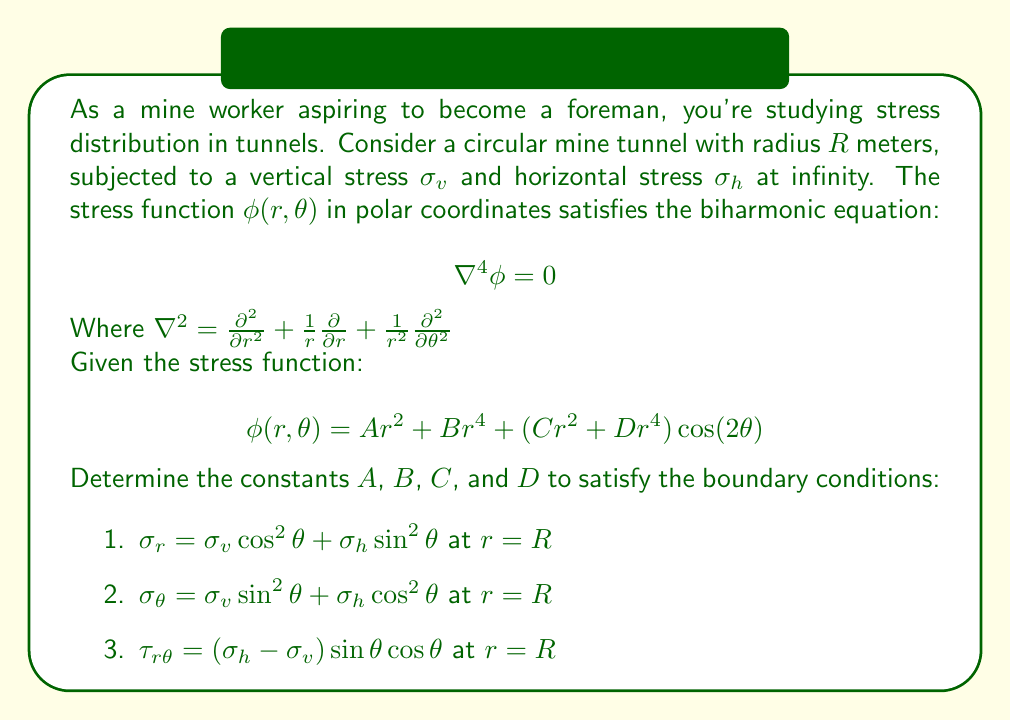Can you answer this question? Let's solve this step-by-step:

1) First, we need to express $\sigma_r$, $\sigma_\theta$, and $\tau_{r\theta}$ in terms of $\phi$:

   $$\sigma_r = \frac{1}{r}\frac{\partial \phi}{\partial r} + \frac{1}{r^2}\frac{\partial^2 \phi}{\partial \theta^2}$$
   $$\sigma_\theta = \frac{\partial^2 \phi}{\partial r^2}$$
   $$\tau_{r\theta} = -\frac{\partial}{\partial r}\left(\frac{1}{r}\frac{\partial \phi}{\partial \theta}\right)$$

2) Substituting the given $\phi(r,\theta)$ into these equations:

   $$\sigma_r = 2A + 4Br^2 + (2C + 4Dr^2)\cos(2\theta)$$
   $$\sigma_\theta = 2A + 12Br^2 + (2C + 12Dr^2)\cos(2\theta)$$
   $$\tau_{r\theta} = (-2C - 4Dr^2)\sin(2\theta)$$

3) Applying the boundary conditions at $r = R$:

   $$2A + 4BR^2 + (2C + 4DR^2)\cos(2\theta) = \sigma_v \cos^2\theta + \sigma_h \sin^2\theta$$
   $$2A + 12BR^2 + (2C + 12DR^2)\cos(2\theta) = \sigma_v \sin^2\theta + \sigma_h \cos^2\theta$$
   $$(-2C - 4DR^2)\sin(2\theta) = (\sigma_h - \sigma_v) \sin\theta \cos\theta$$

4) Using trigonometric identities:

   $$\cos^2\theta = \frac{1 + \cos(2\theta)}{2}, \sin^2\theta = \frac{1 - \cos(2\theta)}{2}$$
   $$\sin\theta \cos\theta = \frac{1}{2}\sin(2\theta)$$

5) Rewriting the boundary conditions:

   $$2A + 4BR^2 + (2C + 4DR^2)\cos(2\theta) = \frac{\sigma_v + \sigma_h}{2} + \frac{\sigma_v - \sigma_h}{2}\cos(2\theta)$$
   $$2A + 12BR^2 + (2C + 12DR^2)\cos(2\theta) = \frac{\sigma_v + \sigma_h}{2} - \frac{\sigma_v - \sigma_h}{2}\cos(2\theta)$$
   $$(-2C - 4DR^2)\sin(2\theta) = \frac{\sigma_h - \sigma_v}{2}\sin(2\theta)$$

6) Comparing coefficients:

   $$2A + 4BR^2 = \frac{\sigma_v + \sigma_h}{2}$$
   $$2C + 4DR^2 = \frac{\sigma_v - \sigma_h}{2}$$
   $$2A + 12BR^2 = \frac{\sigma_v + \sigma_h}{2}$$
   $$2C + 12DR^2 = -\frac{\sigma_v - \sigma_h}{2}$$
   $$-2C - 4DR^2 = \frac{\sigma_h - \sigma_v}{2}$$

7) Solving these equations:

   $$A = \frac{\sigma_v + \sigma_h}{4}$$
   $$B = -\frac{\sigma_v + \sigma_h}{8R^2}$$
   $$C = \frac{\sigma_v - \sigma_h}{4}$$
   $$D = -\frac{\sigma_v - \sigma_h}{8R^2}$$
Answer: $A = \frac{\sigma_v + \sigma_h}{4}$, $B = -\frac{\sigma_v + \sigma_h}{8R^2}$, $C = \frac{\sigma_v - \sigma_h}{4}$, $D = -\frac{\sigma_v - \sigma_h}{8R^2}$ 